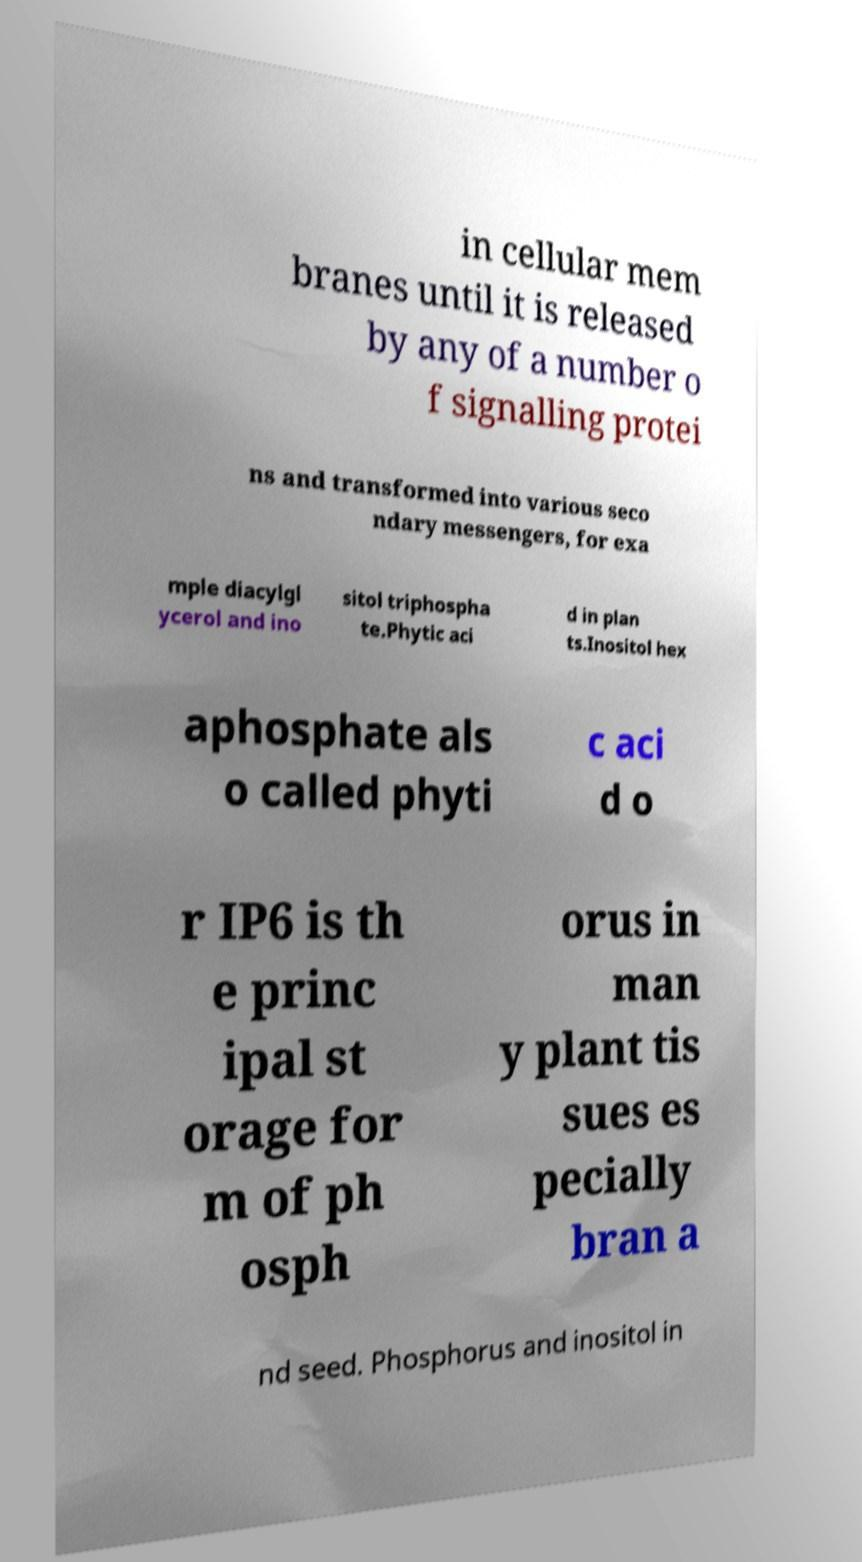Please identify and transcribe the text found in this image. in cellular mem branes until it is released by any of a number o f signalling protei ns and transformed into various seco ndary messengers, for exa mple diacylgl ycerol and ino sitol triphospha te.Phytic aci d in plan ts.Inositol hex aphosphate als o called phyti c aci d o r IP6 is th e princ ipal st orage for m of ph osph orus in man y plant tis sues es pecially bran a nd seed. Phosphorus and inositol in 